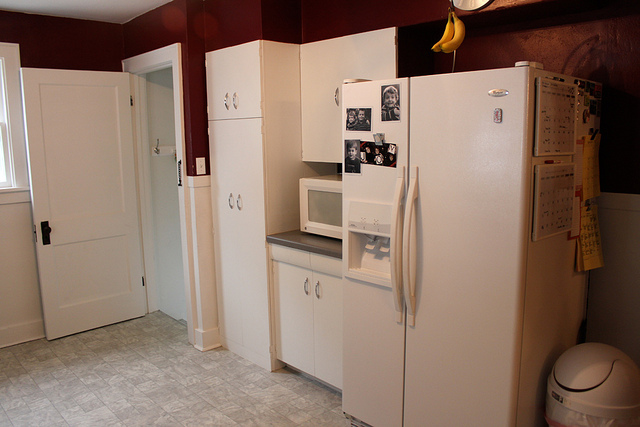Can you tell me what kind of flooring this kitchen has? The kitchen floor appears to be covered with vinyl flooring, featuring a pattern that resembles tiles. 